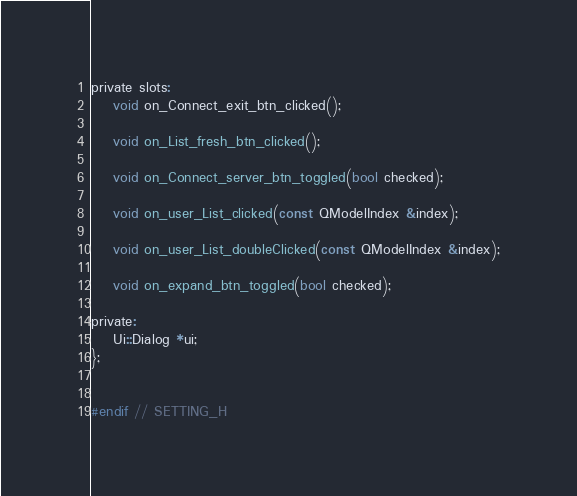<code> <loc_0><loc_0><loc_500><loc_500><_C_>private slots:
    void on_Connect_exit_btn_clicked();

    void on_List_fresh_btn_clicked();

    void on_Connect_server_btn_toggled(bool checked);

    void on_user_List_clicked(const QModelIndex &index);

    void on_user_List_doubleClicked(const QModelIndex &index);

    void on_expand_btn_toggled(bool checked);

private:
    Ui::Dialog *ui;
};


#endif // SETTING_H
</code> 